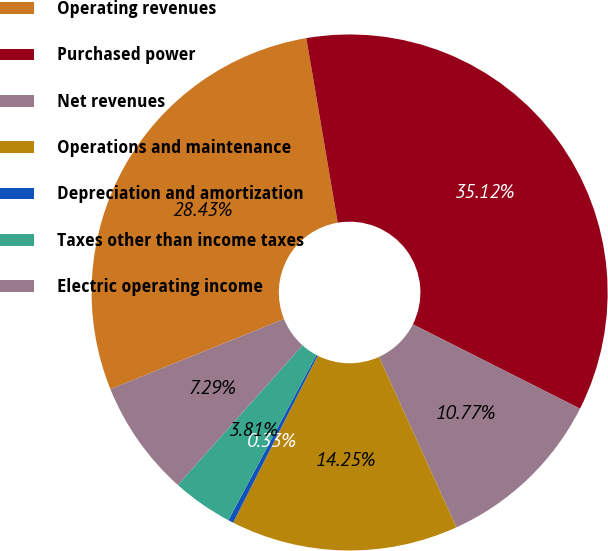Convert chart to OTSL. <chart><loc_0><loc_0><loc_500><loc_500><pie_chart><fcel>Operating revenues<fcel>Purchased power<fcel>Net revenues<fcel>Operations and maintenance<fcel>Depreciation and amortization<fcel>Taxes other than income taxes<fcel>Electric operating income<nl><fcel>28.43%<fcel>35.12%<fcel>10.77%<fcel>14.25%<fcel>0.33%<fcel>3.81%<fcel>7.29%<nl></chart> 